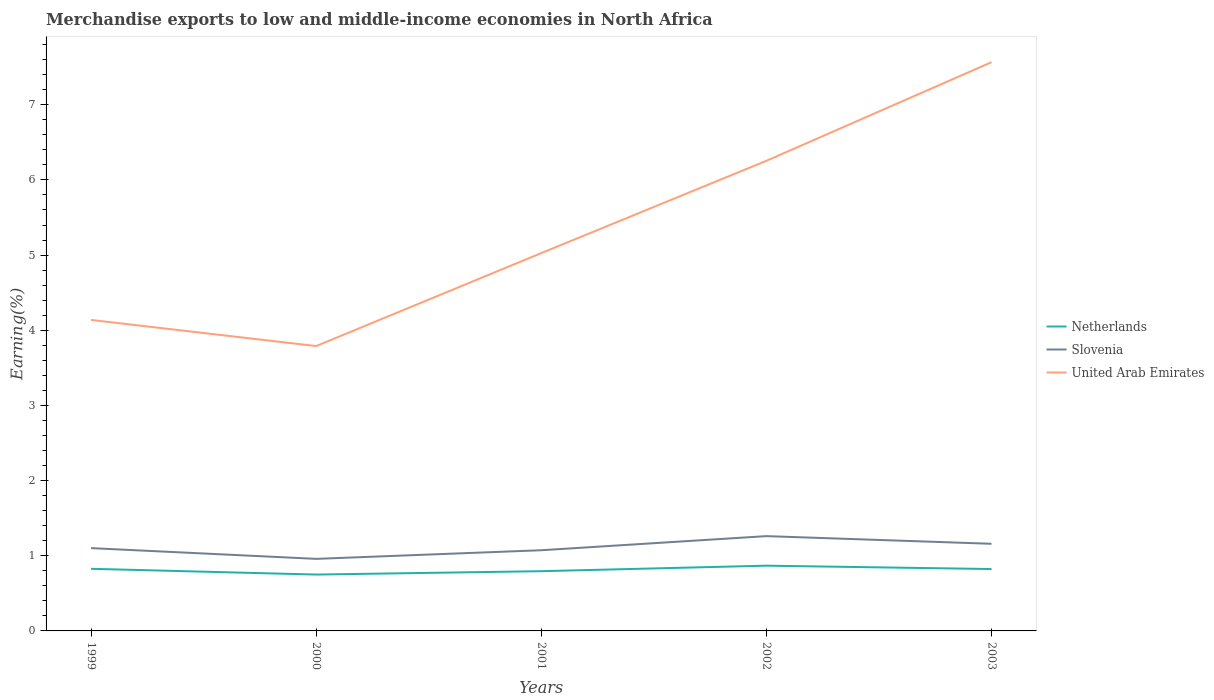How many different coloured lines are there?
Your response must be concise. 3. Does the line corresponding to Slovenia intersect with the line corresponding to United Arab Emirates?
Offer a terse response. No. Across all years, what is the maximum percentage of amount earned from merchandise exports in United Arab Emirates?
Provide a short and direct response. 3.79. What is the total percentage of amount earned from merchandise exports in United Arab Emirates in the graph?
Ensure brevity in your answer.  0.35. What is the difference between the highest and the second highest percentage of amount earned from merchandise exports in United Arab Emirates?
Offer a very short reply. 3.78. What is the difference between the highest and the lowest percentage of amount earned from merchandise exports in Netherlands?
Give a very brief answer. 3. How many lines are there?
Give a very brief answer. 3. How many years are there in the graph?
Provide a succinct answer. 5. Does the graph contain any zero values?
Keep it short and to the point. No. Where does the legend appear in the graph?
Make the answer very short. Center right. How many legend labels are there?
Provide a short and direct response. 3. How are the legend labels stacked?
Ensure brevity in your answer.  Vertical. What is the title of the graph?
Your answer should be very brief. Merchandise exports to low and middle-income economies in North Africa. What is the label or title of the X-axis?
Your answer should be compact. Years. What is the label or title of the Y-axis?
Provide a succinct answer. Earning(%). What is the Earning(%) in Netherlands in 1999?
Your response must be concise. 0.83. What is the Earning(%) of Slovenia in 1999?
Provide a short and direct response. 1.1. What is the Earning(%) in United Arab Emirates in 1999?
Keep it short and to the point. 4.14. What is the Earning(%) of Netherlands in 2000?
Your answer should be compact. 0.75. What is the Earning(%) of Slovenia in 2000?
Offer a terse response. 0.96. What is the Earning(%) of United Arab Emirates in 2000?
Offer a very short reply. 3.79. What is the Earning(%) in Netherlands in 2001?
Your answer should be very brief. 0.79. What is the Earning(%) of Slovenia in 2001?
Provide a short and direct response. 1.07. What is the Earning(%) in United Arab Emirates in 2001?
Provide a short and direct response. 5.03. What is the Earning(%) in Netherlands in 2002?
Offer a terse response. 0.87. What is the Earning(%) in Slovenia in 2002?
Your answer should be very brief. 1.26. What is the Earning(%) of United Arab Emirates in 2002?
Provide a succinct answer. 6.25. What is the Earning(%) in Netherlands in 2003?
Ensure brevity in your answer.  0.82. What is the Earning(%) of Slovenia in 2003?
Give a very brief answer. 1.16. What is the Earning(%) of United Arab Emirates in 2003?
Give a very brief answer. 7.57. Across all years, what is the maximum Earning(%) of Netherlands?
Your answer should be compact. 0.87. Across all years, what is the maximum Earning(%) in Slovenia?
Ensure brevity in your answer.  1.26. Across all years, what is the maximum Earning(%) in United Arab Emirates?
Your response must be concise. 7.57. Across all years, what is the minimum Earning(%) in Netherlands?
Your response must be concise. 0.75. Across all years, what is the minimum Earning(%) of Slovenia?
Your answer should be very brief. 0.96. Across all years, what is the minimum Earning(%) in United Arab Emirates?
Keep it short and to the point. 3.79. What is the total Earning(%) in Netherlands in the graph?
Keep it short and to the point. 4.06. What is the total Earning(%) in Slovenia in the graph?
Your response must be concise. 5.55. What is the total Earning(%) in United Arab Emirates in the graph?
Make the answer very short. 26.77. What is the difference between the Earning(%) of Netherlands in 1999 and that in 2000?
Provide a succinct answer. 0.08. What is the difference between the Earning(%) of Slovenia in 1999 and that in 2000?
Offer a terse response. 0.14. What is the difference between the Earning(%) of United Arab Emirates in 1999 and that in 2000?
Keep it short and to the point. 0.35. What is the difference between the Earning(%) of Netherlands in 1999 and that in 2001?
Ensure brevity in your answer.  0.03. What is the difference between the Earning(%) in Slovenia in 1999 and that in 2001?
Ensure brevity in your answer.  0.03. What is the difference between the Earning(%) of United Arab Emirates in 1999 and that in 2001?
Give a very brief answer. -0.89. What is the difference between the Earning(%) of Netherlands in 1999 and that in 2002?
Provide a succinct answer. -0.04. What is the difference between the Earning(%) of Slovenia in 1999 and that in 2002?
Offer a very short reply. -0.16. What is the difference between the Earning(%) of United Arab Emirates in 1999 and that in 2002?
Your answer should be compact. -2.12. What is the difference between the Earning(%) of Netherlands in 1999 and that in 2003?
Offer a very short reply. 0. What is the difference between the Earning(%) of Slovenia in 1999 and that in 2003?
Keep it short and to the point. -0.06. What is the difference between the Earning(%) in United Arab Emirates in 1999 and that in 2003?
Keep it short and to the point. -3.43. What is the difference between the Earning(%) in Netherlands in 2000 and that in 2001?
Your answer should be compact. -0.04. What is the difference between the Earning(%) of Slovenia in 2000 and that in 2001?
Your response must be concise. -0.11. What is the difference between the Earning(%) in United Arab Emirates in 2000 and that in 2001?
Offer a terse response. -1.24. What is the difference between the Earning(%) of Netherlands in 2000 and that in 2002?
Make the answer very short. -0.12. What is the difference between the Earning(%) in Slovenia in 2000 and that in 2002?
Offer a terse response. -0.3. What is the difference between the Earning(%) in United Arab Emirates in 2000 and that in 2002?
Provide a succinct answer. -2.46. What is the difference between the Earning(%) of Netherlands in 2000 and that in 2003?
Provide a short and direct response. -0.07. What is the difference between the Earning(%) of Slovenia in 2000 and that in 2003?
Offer a very short reply. -0.2. What is the difference between the Earning(%) of United Arab Emirates in 2000 and that in 2003?
Your answer should be very brief. -3.78. What is the difference between the Earning(%) of Netherlands in 2001 and that in 2002?
Make the answer very short. -0.07. What is the difference between the Earning(%) of Slovenia in 2001 and that in 2002?
Make the answer very short. -0.19. What is the difference between the Earning(%) of United Arab Emirates in 2001 and that in 2002?
Give a very brief answer. -1.23. What is the difference between the Earning(%) in Netherlands in 2001 and that in 2003?
Your answer should be compact. -0.03. What is the difference between the Earning(%) of Slovenia in 2001 and that in 2003?
Make the answer very short. -0.09. What is the difference between the Earning(%) of United Arab Emirates in 2001 and that in 2003?
Make the answer very short. -2.54. What is the difference between the Earning(%) in Netherlands in 2002 and that in 2003?
Your answer should be compact. 0.04. What is the difference between the Earning(%) of Slovenia in 2002 and that in 2003?
Ensure brevity in your answer.  0.1. What is the difference between the Earning(%) in United Arab Emirates in 2002 and that in 2003?
Give a very brief answer. -1.31. What is the difference between the Earning(%) of Netherlands in 1999 and the Earning(%) of Slovenia in 2000?
Give a very brief answer. -0.13. What is the difference between the Earning(%) in Netherlands in 1999 and the Earning(%) in United Arab Emirates in 2000?
Provide a short and direct response. -2.96. What is the difference between the Earning(%) in Slovenia in 1999 and the Earning(%) in United Arab Emirates in 2000?
Your response must be concise. -2.69. What is the difference between the Earning(%) of Netherlands in 1999 and the Earning(%) of Slovenia in 2001?
Keep it short and to the point. -0.25. What is the difference between the Earning(%) in Netherlands in 1999 and the Earning(%) in United Arab Emirates in 2001?
Keep it short and to the point. -4.2. What is the difference between the Earning(%) of Slovenia in 1999 and the Earning(%) of United Arab Emirates in 2001?
Offer a terse response. -3.92. What is the difference between the Earning(%) of Netherlands in 1999 and the Earning(%) of Slovenia in 2002?
Provide a succinct answer. -0.43. What is the difference between the Earning(%) of Netherlands in 1999 and the Earning(%) of United Arab Emirates in 2002?
Ensure brevity in your answer.  -5.43. What is the difference between the Earning(%) of Slovenia in 1999 and the Earning(%) of United Arab Emirates in 2002?
Offer a very short reply. -5.15. What is the difference between the Earning(%) in Netherlands in 1999 and the Earning(%) in Slovenia in 2003?
Give a very brief answer. -0.33. What is the difference between the Earning(%) of Netherlands in 1999 and the Earning(%) of United Arab Emirates in 2003?
Offer a terse response. -6.74. What is the difference between the Earning(%) of Slovenia in 1999 and the Earning(%) of United Arab Emirates in 2003?
Make the answer very short. -6.46. What is the difference between the Earning(%) in Netherlands in 2000 and the Earning(%) in Slovenia in 2001?
Your answer should be very brief. -0.32. What is the difference between the Earning(%) of Netherlands in 2000 and the Earning(%) of United Arab Emirates in 2001?
Keep it short and to the point. -4.28. What is the difference between the Earning(%) of Slovenia in 2000 and the Earning(%) of United Arab Emirates in 2001?
Ensure brevity in your answer.  -4.07. What is the difference between the Earning(%) of Netherlands in 2000 and the Earning(%) of Slovenia in 2002?
Ensure brevity in your answer.  -0.51. What is the difference between the Earning(%) in Netherlands in 2000 and the Earning(%) in United Arab Emirates in 2002?
Offer a terse response. -5.5. What is the difference between the Earning(%) of Slovenia in 2000 and the Earning(%) of United Arab Emirates in 2002?
Give a very brief answer. -5.3. What is the difference between the Earning(%) of Netherlands in 2000 and the Earning(%) of Slovenia in 2003?
Provide a succinct answer. -0.41. What is the difference between the Earning(%) of Netherlands in 2000 and the Earning(%) of United Arab Emirates in 2003?
Offer a terse response. -6.82. What is the difference between the Earning(%) in Slovenia in 2000 and the Earning(%) in United Arab Emirates in 2003?
Your answer should be very brief. -6.61. What is the difference between the Earning(%) of Netherlands in 2001 and the Earning(%) of Slovenia in 2002?
Provide a short and direct response. -0.47. What is the difference between the Earning(%) in Netherlands in 2001 and the Earning(%) in United Arab Emirates in 2002?
Give a very brief answer. -5.46. What is the difference between the Earning(%) of Slovenia in 2001 and the Earning(%) of United Arab Emirates in 2002?
Your response must be concise. -5.18. What is the difference between the Earning(%) in Netherlands in 2001 and the Earning(%) in Slovenia in 2003?
Offer a very short reply. -0.36. What is the difference between the Earning(%) of Netherlands in 2001 and the Earning(%) of United Arab Emirates in 2003?
Provide a short and direct response. -6.77. What is the difference between the Earning(%) in Slovenia in 2001 and the Earning(%) in United Arab Emirates in 2003?
Offer a very short reply. -6.49. What is the difference between the Earning(%) in Netherlands in 2002 and the Earning(%) in Slovenia in 2003?
Provide a short and direct response. -0.29. What is the difference between the Earning(%) of Netherlands in 2002 and the Earning(%) of United Arab Emirates in 2003?
Keep it short and to the point. -6.7. What is the difference between the Earning(%) in Slovenia in 2002 and the Earning(%) in United Arab Emirates in 2003?
Give a very brief answer. -6.3. What is the average Earning(%) of Netherlands per year?
Keep it short and to the point. 0.81. What is the average Earning(%) of Slovenia per year?
Your answer should be compact. 1.11. What is the average Earning(%) of United Arab Emirates per year?
Your response must be concise. 5.35. In the year 1999, what is the difference between the Earning(%) in Netherlands and Earning(%) in Slovenia?
Offer a terse response. -0.28. In the year 1999, what is the difference between the Earning(%) of Netherlands and Earning(%) of United Arab Emirates?
Make the answer very short. -3.31. In the year 1999, what is the difference between the Earning(%) of Slovenia and Earning(%) of United Arab Emirates?
Make the answer very short. -3.04. In the year 2000, what is the difference between the Earning(%) of Netherlands and Earning(%) of Slovenia?
Make the answer very short. -0.21. In the year 2000, what is the difference between the Earning(%) in Netherlands and Earning(%) in United Arab Emirates?
Offer a very short reply. -3.04. In the year 2000, what is the difference between the Earning(%) of Slovenia and Earning(%) of United Arab Emirates?
Provide a short and direct response. -2.83. In the year 2001, what is the difference between the Earning(%) of Netherlands and Earning(%) of Slovenia?
Provide a short and direct response. -0.28. In the year 2001, what is the difference between the Earning(%) of Netherlands and Earning(%) of United Arab Emirates?
Ensure brevity in your answer.  -4.23. In the year 2001, what is the difference between the Earning(%) of Slovenia and Earning(%) of United Arab Emirates?
Make the answer very short. -3.95. In the year 2002, what is the difference between the Earning(%) in Netherlands and Earning(%) in Slovenia?
Your response must be concise. -0.39. In the year 2002, what is the difference between the Earning(%) of Netherlands and Earning(%) of United Arab Emirates?
Offer a terse response. -5.39. In the year 2002, what is the difference between the Earning(%) of Slovenia and Earning(%) of United Arab Emirates?
Make the answer very short. -4.99. In the year 2003, what is the difference between the Earning(%) in Netherlands and Earning(%) in Slovenia?
Your response must be concise. -0.34. In the year 2003, what is the difference between the Earning(%) in Netherlands and Earning(%) in United Arab Emirates?
Ensure brevity in your answer.  -6.74. In the year 2003, what is the difference between the Earning(%) in Slovenia and Earning(%) in United Arab Emirates?
Your answer should be very brief. -6.41. What is the ratio of the Earning(%) in Netherlands in 1999 to that in 2000?
Your response must be concise. 1.1. What is the ratio of the Earning(%) of Slovenia in 1999 to that in 2000?
Your response must be concise. 1.15. What is the ratio of the Earning(%) in United Arab Emirates in 1999 to that in 2000?
Give a very brief answer. 1.09. What is the ratio of the Earning(%) in Netherlands in 1999 to that in 2001?
Keep it short and to the point. 1.04. What is the ratio of the Earning(%) in Slovenia in 1999 to that in 2001?
Provide a succinct answer. 1.03. What is the ratio of the Earning(%) of United Arab Emirates in 1999 to that in 2001?
Give a very brief answer. 0.82. What is the ratio of the Earning(%) of Netherlands in 1999 to that in 2002?
Keep it short and to the point. 0.95. What is the ratio of the Earning(%) of Slovenia in 1999 to that in 2002?
Keep it short and to the point. 0.87. What is the ratio of the Earning(%) in United Arab Emirates in 1999 to that in 2002?
Ensure brevity in your answer.  0.66. What is the ratio of the Earning(%) of Slovenia in 1999 to that in 2003?
Your answer should be compact. 0.95. What is the ratio of the Earning(%) of United Arab Emirates in 1999 to that in 2003?
Give a very brief answer. 0.55. What is the ratio of the Earning(%) in Netherlands in 2000 to that in 2001?
Provide a succinct answer. 0.94. What is the ratio of the Earning(%) of Slovenia in 2000 to that in 2001?
Give a very brief answer. 0.89. What is the ratio of the Earning(%) of United Arab Emirates in 2000 to that in 2001?
Your response must be concise. 0.75. What is the ratio of the Earning(%) of Netherlands in 2000 to that in 2002?
Your response must be concise. 0.86. What is the ratio of the Earning(%) in Slovenia in 2000 to that in 2002?
Offer a terse response. 0.76. What is the ratio of the Earning(%) of United Arab Emirates in 2000 to that in 2002?
Your answer should be compact. 0.61. What is the ratio of the Earning(%) in Netherlands in 2000 to that in 2003?
Give a very brief answer. 0.91. What is the ratio of the Earning(%) in Slovenia in 2000 to that in 2003?
Make the answer very short. 0.83. What is the ratio of the Earning(%) in United Arab Emirates in 2000 to that in 2003?
Offer a terse response. 0.5. What is the ratio of the Earning(%) of Netherlands in 2001 to that in 2002?
Your response must be concise. 0.92. What is the ratio of the Earning(%) of Slovenia in 2001 to that in 2002?
Your answer should be very brief. 0.85. What is the ratio of the Earning(%) of United Arab Emirates in 2001 to that in 2002?
Your response must be concise. 0.8. What is the ratio of the Earning(%) in Netherlands in 2001 to that in 2003?
Ensure brevity in your answer.  0.97. What is the ratio of the Earning(%) of Slovenia in 2001 to that in 2003?
Offer a very short reply. 0.93. What is the ratio of the Earning(%) of United Arab Emirates in 2001 to that in 2003?
Offer a terse response. 0.66. What is the ratio of the Earning(%) of Netherlands in 2002 to that in 2003?
Offer a terse response. 1.05. What is the ratio of the Earning(%) in Slovenia in 2002 to that in 2003?
Provide a short and direct response. 1.09. What is the ratio of the Earning(%) in United Arab Emirates in 2002 to that in 2003?
Your answer should be compact. 0.83. What is the difference between the highest and the second highest Earning(%) in Netherlands?
Ensure brevity in your answer.  0.04. What is the difference between the highest and the second highest Earning(%) of Slovenia?
Provide a short and direct response. 0.1. What is the difference between the highest and the second highest Earning(%) in United Arab Emirates?
Provide a succinct answer. 1.31. What is the difference between the highest and the lowest Earning(%) in Netherlands?
Offer a very short reply. 0.12. What is the difference between the highest and the lowest Earning(%) in Slovenia?
Your response must be concise. 0.3. What is the difference between the highest and the lowest Earning(%) of United Arab Emirates?
Your response must be concise. 3.78. 